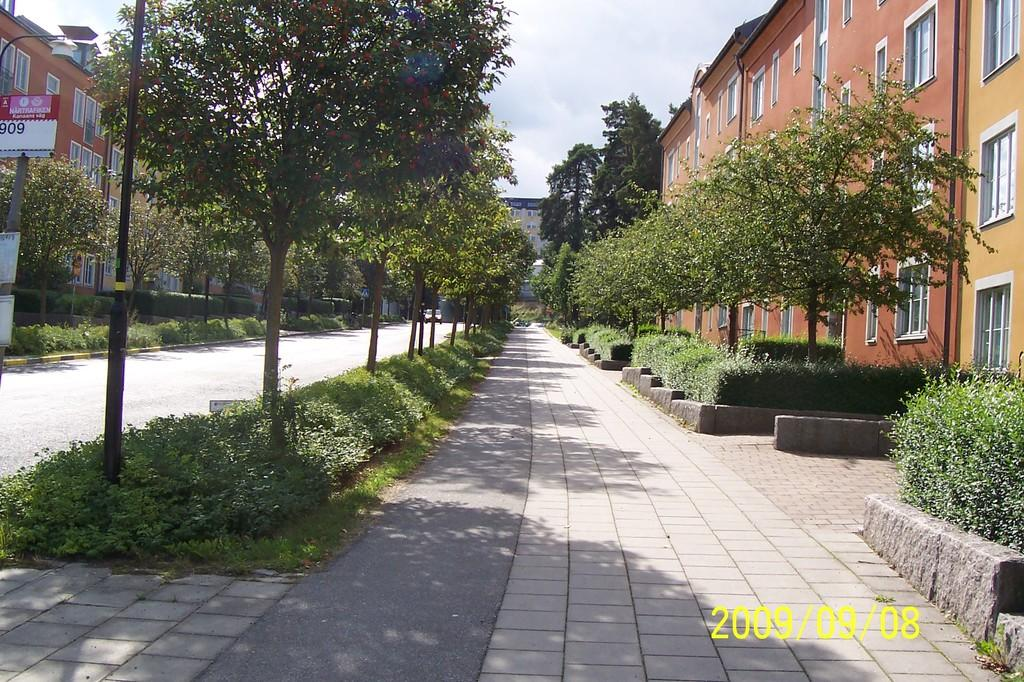What type of living organisms can be seen in the image? Plants and trees are visible in the image. What type of structures can be seen in the image? There are buildings in the image. What type of transportation can be seen in the image? There are vehicles in the image. What is visible at the top of the image? Clouds and the sky are visible at the top of the image. What type of boot is being worn by the tree in the image? There are no boots present in the image, as trees do not wear boots. 